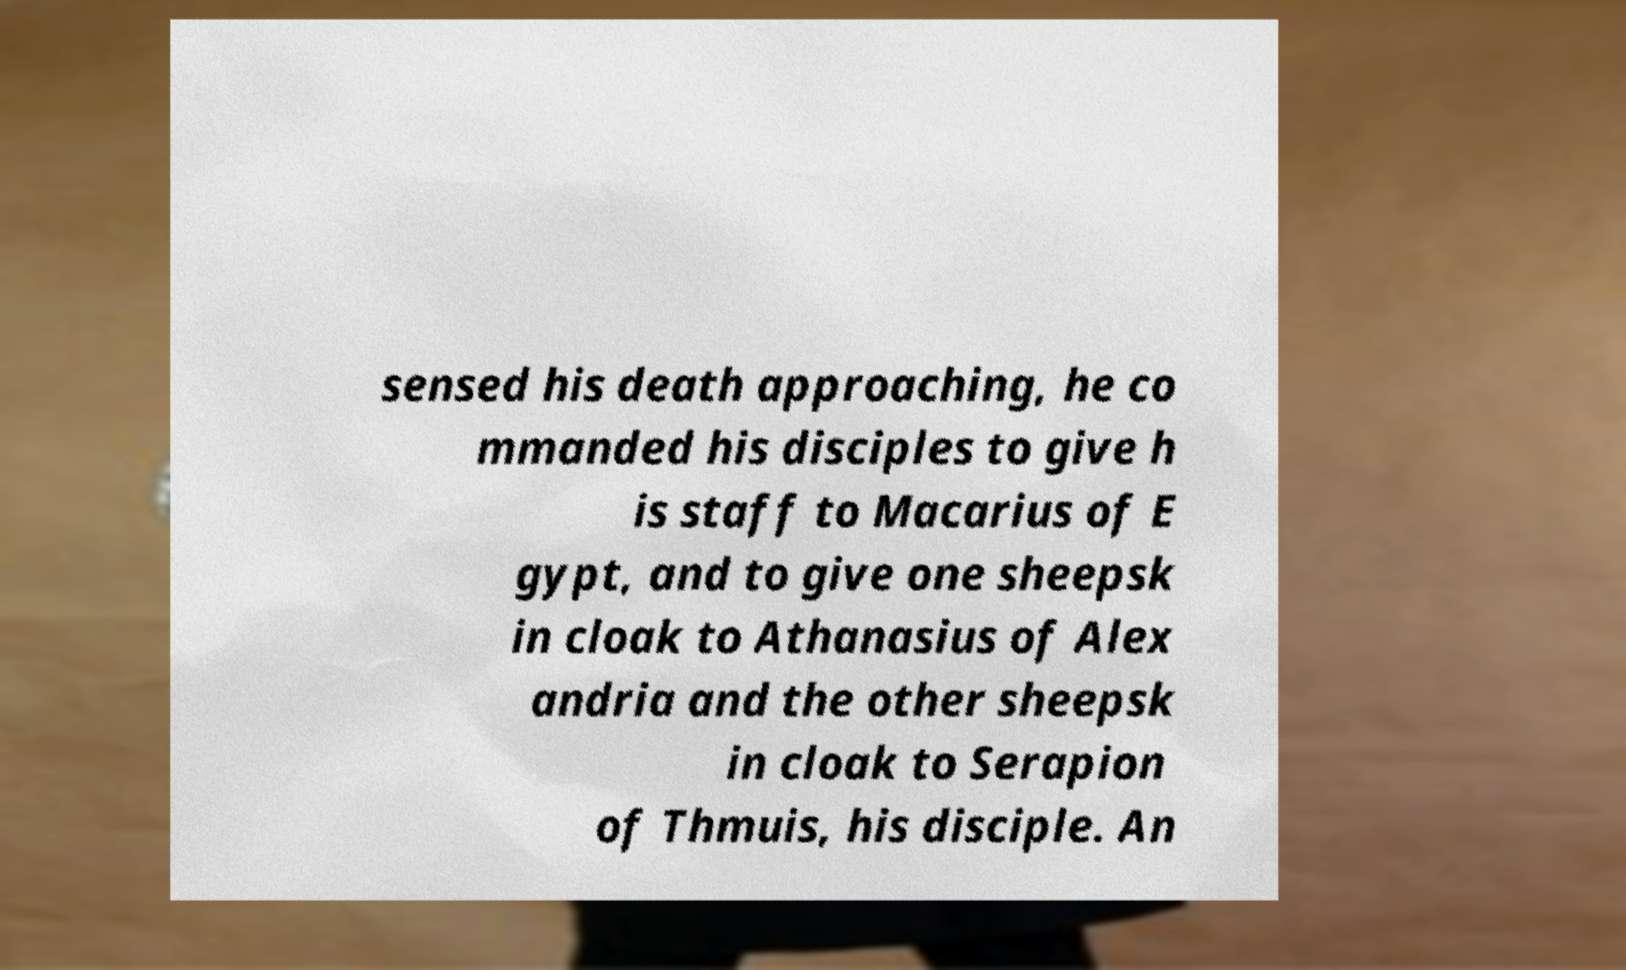Please identify and transcribe the text found in this image. sensed his death approaching, he co mmanded his disciples to give h is staff to Macarius of E gypt, and to give one sheepsk in cloak to Athanasius of Alex andria and the other sheepsk in cloak to Serapion of Thmuis, his disciple. An 